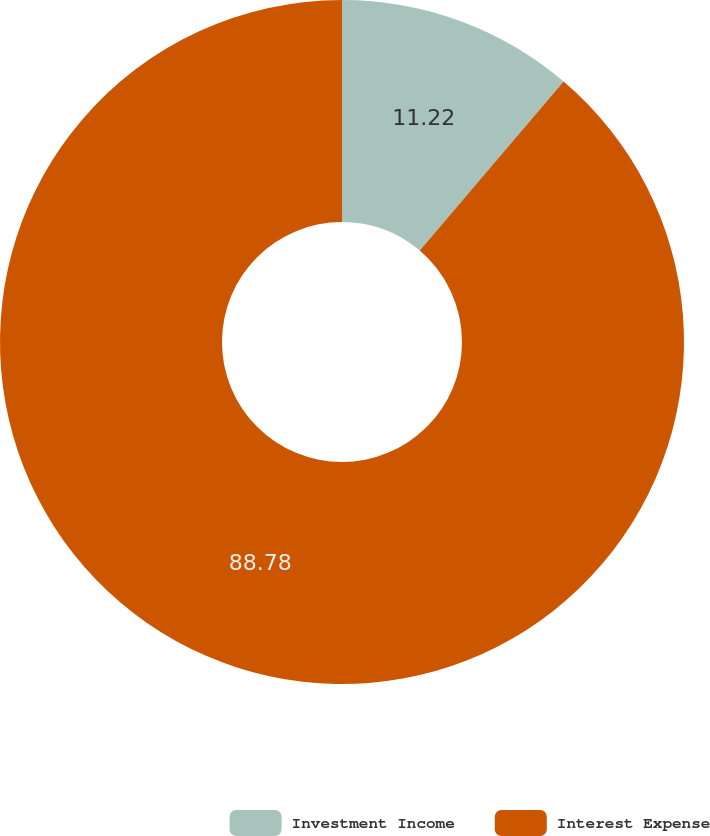Convert chart. <chart><loc_0><loc_0><loc_500><loc_500><pie_chart><fcel>Investment Income<fcel>Interest Expense<nl><fcel>11.22%<fcel>88.78%<nl></chart> 